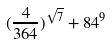Convert formula to latex. <formula><loc_0><loc_0><loc_500><loc_500>( \frac { 4 } { 3 6 4 } ) ^ { \sqrt { 7 } } + 8 4 ^ { 9 }</formula> 